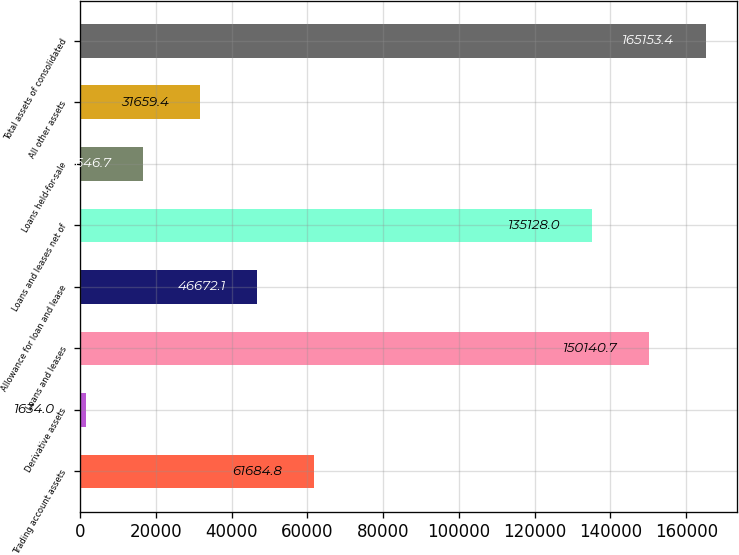Convert chart to OTSL. <chart><loc_0><loc_0><loc_500><loc_500><bar_chart><fcel>Trading account assets<fcel>Derivative assets<fcel>Loans and leases<fcel>Allowance for loan and lease<fcel>Loans and leases net of<fcel>Loans held-for-sale<fcel>All other assets<fcel>Total assets of consolidated<nl><fcel>61684.8<fcel>1634<fcel>150141<fcel>46672.1<fcel>135128<fcel>16646.7<fcel>31659.4<fcel>165153<nl></chart> 